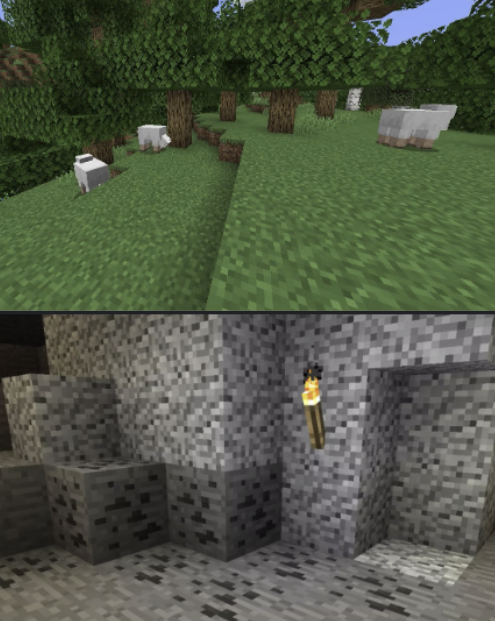You are a Minecraft Player. Your current high-level task is: 'mine redstone'. Your current low-level task is: 'find a creeper'. Your inventory has the following in it: nothing.

First, critique your low-level task in light of your high-level task, keeping your inventory in mind. If it is not the appropriate low-level task, please suggest a different one -- if you do, proceed with the assumption that your current low-level task is the one you suggested.

There are two scenes provided, top and bottom. Please describe them both, as though you were trying to convey the image to a blind person. Be specific, but don't give unnecessary emotional descriptions. For instance, if the image were of a forest biome, "a lush verdant forest, beautiful and pleasing to the eye" would be a bad description; a better description would be "A forest biome. You see many birch trees. There is a sheep in the distance. There is one sapling on the ground. It is daytime." In your final description, take note of any details that may be relevant to your current low-level task.

Then, rate the desirability of both scenes, given your current tasks and inventory. Explain your reasoning, and indicate which scene you prefer. Your response MUST include one of the following phrases: "I prefer the top"; "I prefer the bottom"; or, in the case where both are equally preferable (or equally bad) "I prefer neither". ### Task Critique

**High-level task:** Mine redstone.

**Current low-level task:** Find a creeper.

**Inventory:** Nothing.

Critique: Finding a creeper is not directly related to mining redstone. Redstone is typically found in the lower levels of the world, particularly between levels 1 and 16, usually in caves or near bedrock. A more appropriate low-level task would be to find a cave or start digging down to reach the levels where redstone is commonly found.

**Suggested low-level task:** Find a cave.

### Scene Descriptions

**Top Scene:**
A grassy plains biome. The scene features several sheep grazing on grass. There are numerous trees scattered around, mainly oak trees. It is daytime.

**Bottom Scene:**
A cave or underground area. The walls are made of stone and some coal ore. There is a torch mounted on the wall providing light. The floor is made of stone, and another section of the wall appears to be slightly dug out.

### Scene Desirability

**Top Scene:**
- **Advantages:** Presence of animals (sheep) for potential wool and food.
- **Disadvantages:** No immediate indication of a cave or any redstone. Open and above ground, which is not conducive to finding redstone.

**Bottom Scene:**
- **Advantages:** This is an underground area, which is more aligned with the task of finding redstone. The presence of coal ore is beneficial for crafting torches, which are necessary for exploring further.
- **Disadvantages:** Limited resources visible other than coal, and no immediate sign of redstone.

Given the high-level task of mining redstone, the underground scene is more desirable as it is closer to where redstone is likely to be found.

**I prefer the bottom.** 